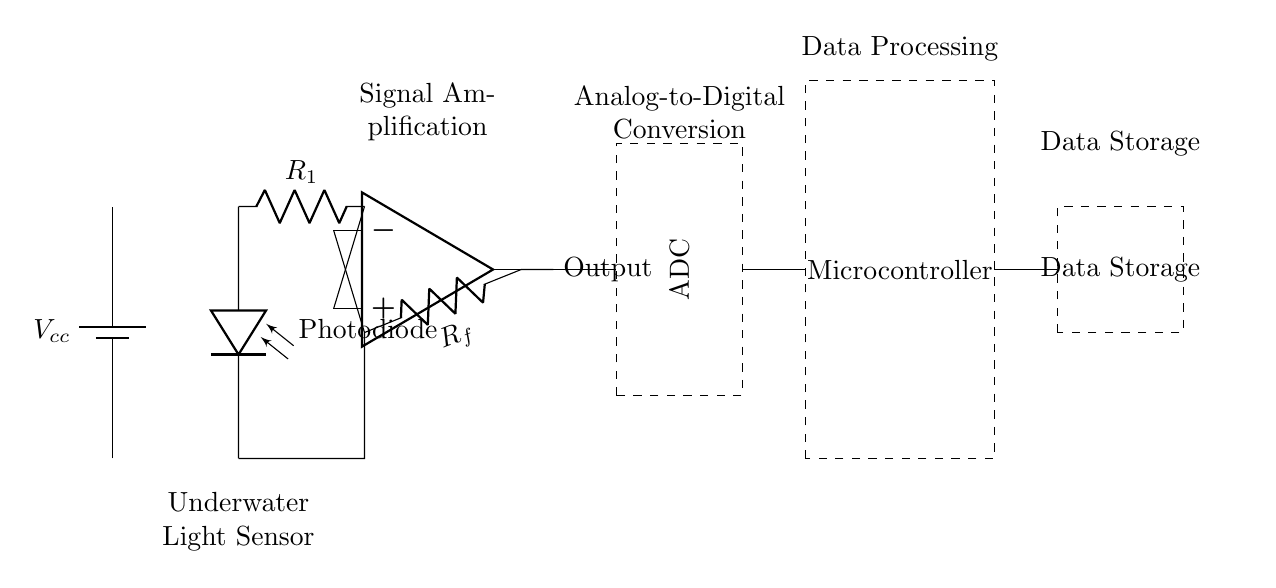What is the purpose of the photodiode in this circuit? The photodiode converts light from bioluminescent organisms into an electrical signal, allowing measurement of light intensity.
Answer: Light detection What is the function of the operational amplifier? The operational amplifier amplifies the small voltage signal from the photodiode, making it suitable for further processing.
Answer: Signal amplification What type of component is used for analog-to-digital conversion in this circuit? The analog-to-digital converter (ADC) transforms the analog signal from the operational amplifier into a digital signal for processing by the microcontroller.
Answer: ADC What is the role of the feedback resistor in this circuit? The feedback resistor helps set the gain of the operational amplifier, controlling how much the signal is amplified.
Answer: Gain control How many main functional blocks are present in this circuit? There are five main functional blocks: the photodiode, operational amplifier, ADC, microcontroller, and data storage.
Answer: Five What connects the operational amplifier output to the ADC? A wire connects the output of the operational amplifier to the input of the ADC for signal conversion.
Answer: A wire 